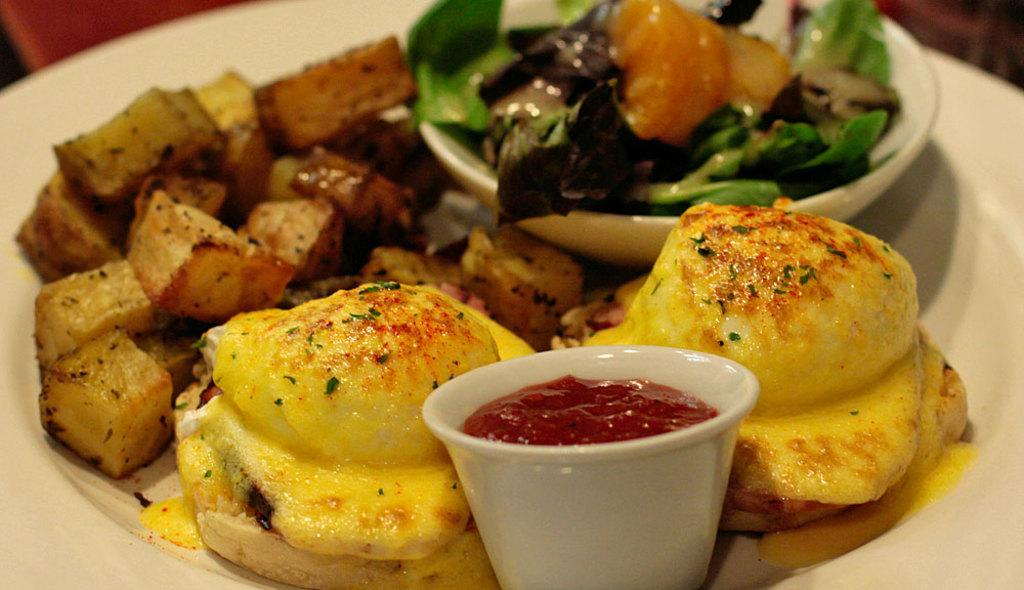What types of items can be seen in the image? There are food items and cups in the image. What color is the plate in the image? The plate is white in color. Where is the playground located in the image? There is no playground present in the image. What type of trade is being conducted in the image? There is no trade being conducted in the image. 